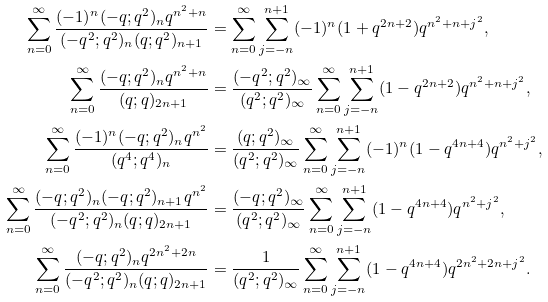<formula> <loc_0><loc_0><loc_500><loc_500>\sum _ { n = 0 } ^ { \infty } \frac { ( - 1 ) ^ { n } ( - q ; q ^ { 2 } ) _ { n } q ^ { n ^ { 2 } + n } } { ( - q ^ { 2 } ; q ^ { 2 } ) _ { n } ( q ; q ^ { 2 } ) _ { n + 1 } } & = \sum _ { n = 0 } ^ { \infty } \sum _ { j = - n } ^ { n + 1 } ( - 1 ) ^ { n } ( 1 + q ^ { 2 n + 2 } ) q ^ { n ^ { 2 } + n + j ^ { 2 } } , \\ \sum _ { n = 0 } ^ { \infty } \frac { ( - q ; q ^ { 2 } ) _ { n } q ^ { n ^ { 2 } + n } } { ( q ; q ) _ { 2 n + 1 } } & = \frac { ( - q ^ { 2 } ; q ^ { 2 } ) _ { \infty } } { ( q ^ { 2 } ; q ^ { 2 } ) _ { \infty } } \sum _ { n = 0 } ^ { \infty } \sum _ { j = - n } ^ { n + 1 } ( 1 - q ^ { 2 n + 2 } ) q ^ { n ^ { 2 } + n + j ^ { 2 } } , \\ \sum _ { n = 0 } ^ { \infty } \frac { ( - 1 ) ^ { n } ( - q ; q ^ { 2 } ) _ { n } q ^ { n ^ { 2 } } } { ( q ^ { 4 } ; q ^ { 4 } ) _ { n } } & = \frac { ( q ; q ^ { 2 } ) _ { \infty } } { ( q ^ { 2 } ; q ^ { 2 } ) _ { \infty } } \sum _ { n = 0 } ^ { \infty } \sum _ { j = - n } ^ { n + 1 } ( - 1 ) ^ { n } ( 1 - q ^ { 4 n + 4 } ) q ^ { n ^ { 2 } + j ^ { 2 } } , \\ \sum _ { n = 0 } ^ { \infty } \frac { ( - q ; q ^ { 2 } ) _ { n } ( - q ; q ^ { 2 } ) _ { n + 1 } q ^ { n ^ { 2 } } } { ( - q ^ { 2 } ; q ^ { 2 } ) _ { n } ( q ; q ) _ { 2 n + 1 } } & = \frac { ( - q ; q ^ { 2 } ) _ { \infty } } { ( q ^ { 2 } ; q ^ { 2 } ) _ { \infty } } \sum _ { n = 0 } ^ { \infty } \sum _ { j = - n } ^ { n + 1 } ( 1 - q ^ { 4 n + 4 } ) q ^ { n ^ { 2 } + j ^ { 2 } } , \\ \sum _ { n = 0 } ^ { \infty } \frac { ( - q ; q ^ { 2 } ) _ { n } q ^ { 2 n ^ { 2 } + 2 n } } { ( - q ^ { 2 } ; q ^ { 2 } ) _ { n } ( q ; q ) _ { 2 n + 1 } } & = \frac { 1 } { ( q ^ { 2 } ; q ^ { 2 } ) _ { \infty } } \sum _ { n = 0 } ^ { \infty } \sum _ { j = - n } ^ { n + 1 } ( 1 - q ^ { 4 n + 4 } ) q ^ { 2 n ^ { 2 } + 2 n + j ^ { 2 } } .</formula> 